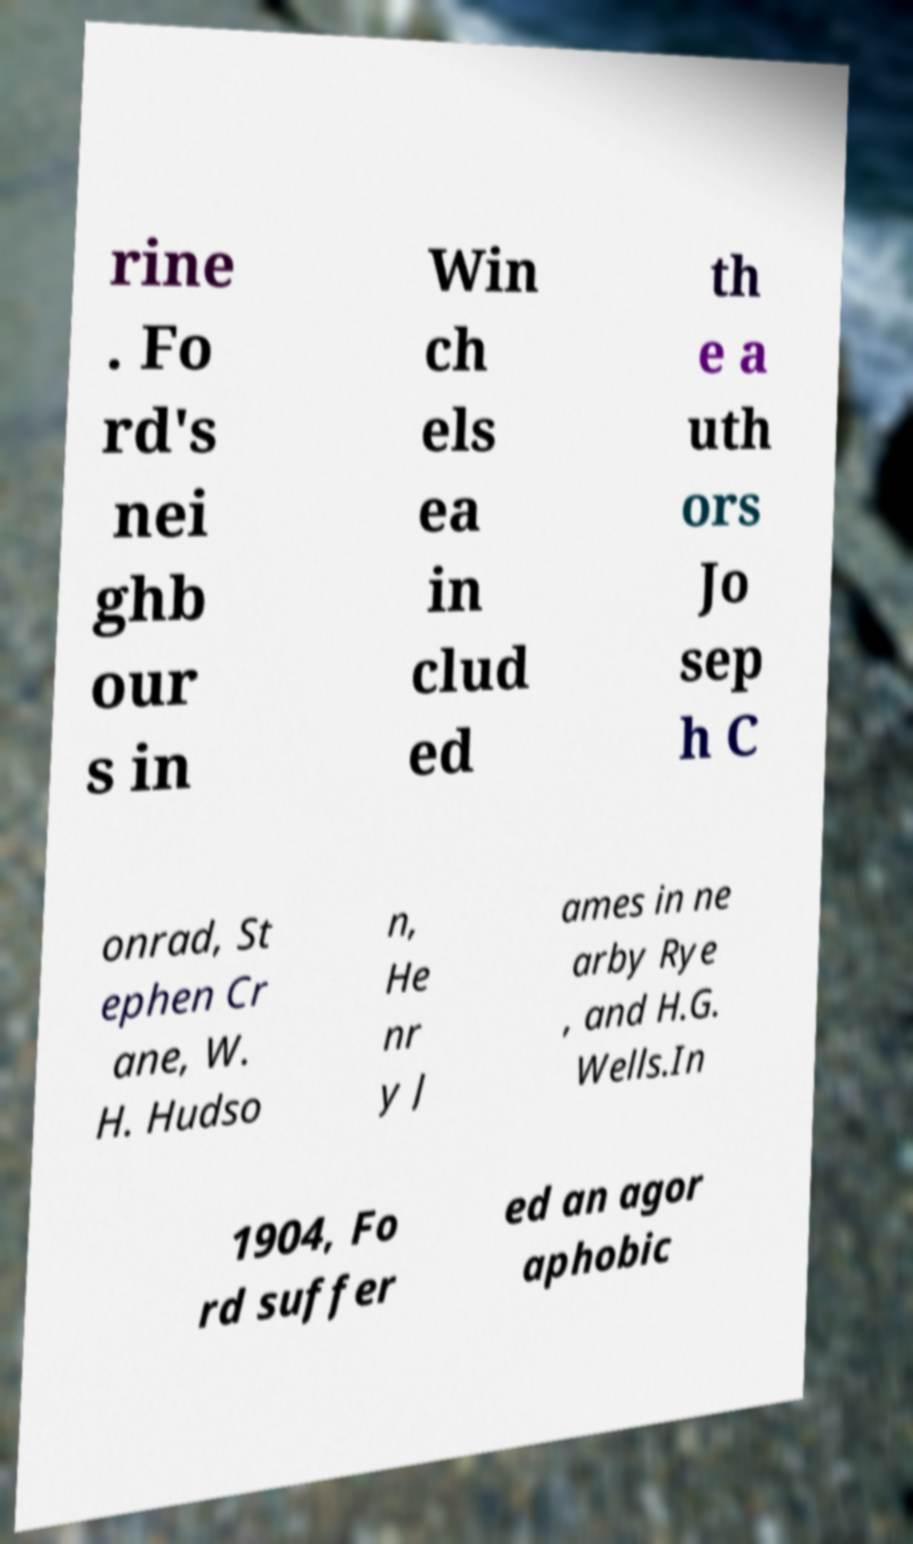For documentation purposes, I need the text within this image transcribed. Could you provide that? rine . Fo rd's nei ghb our s in Win ch els ea in clud ed th e a uth ors Jo sep h C onrad, St ephen Cr ane, W. H. Hudso n, He nr y J ames in ne arby Rye , and H.G. Wells.In 1904, Fo rd suffer ed an agor aphobic 